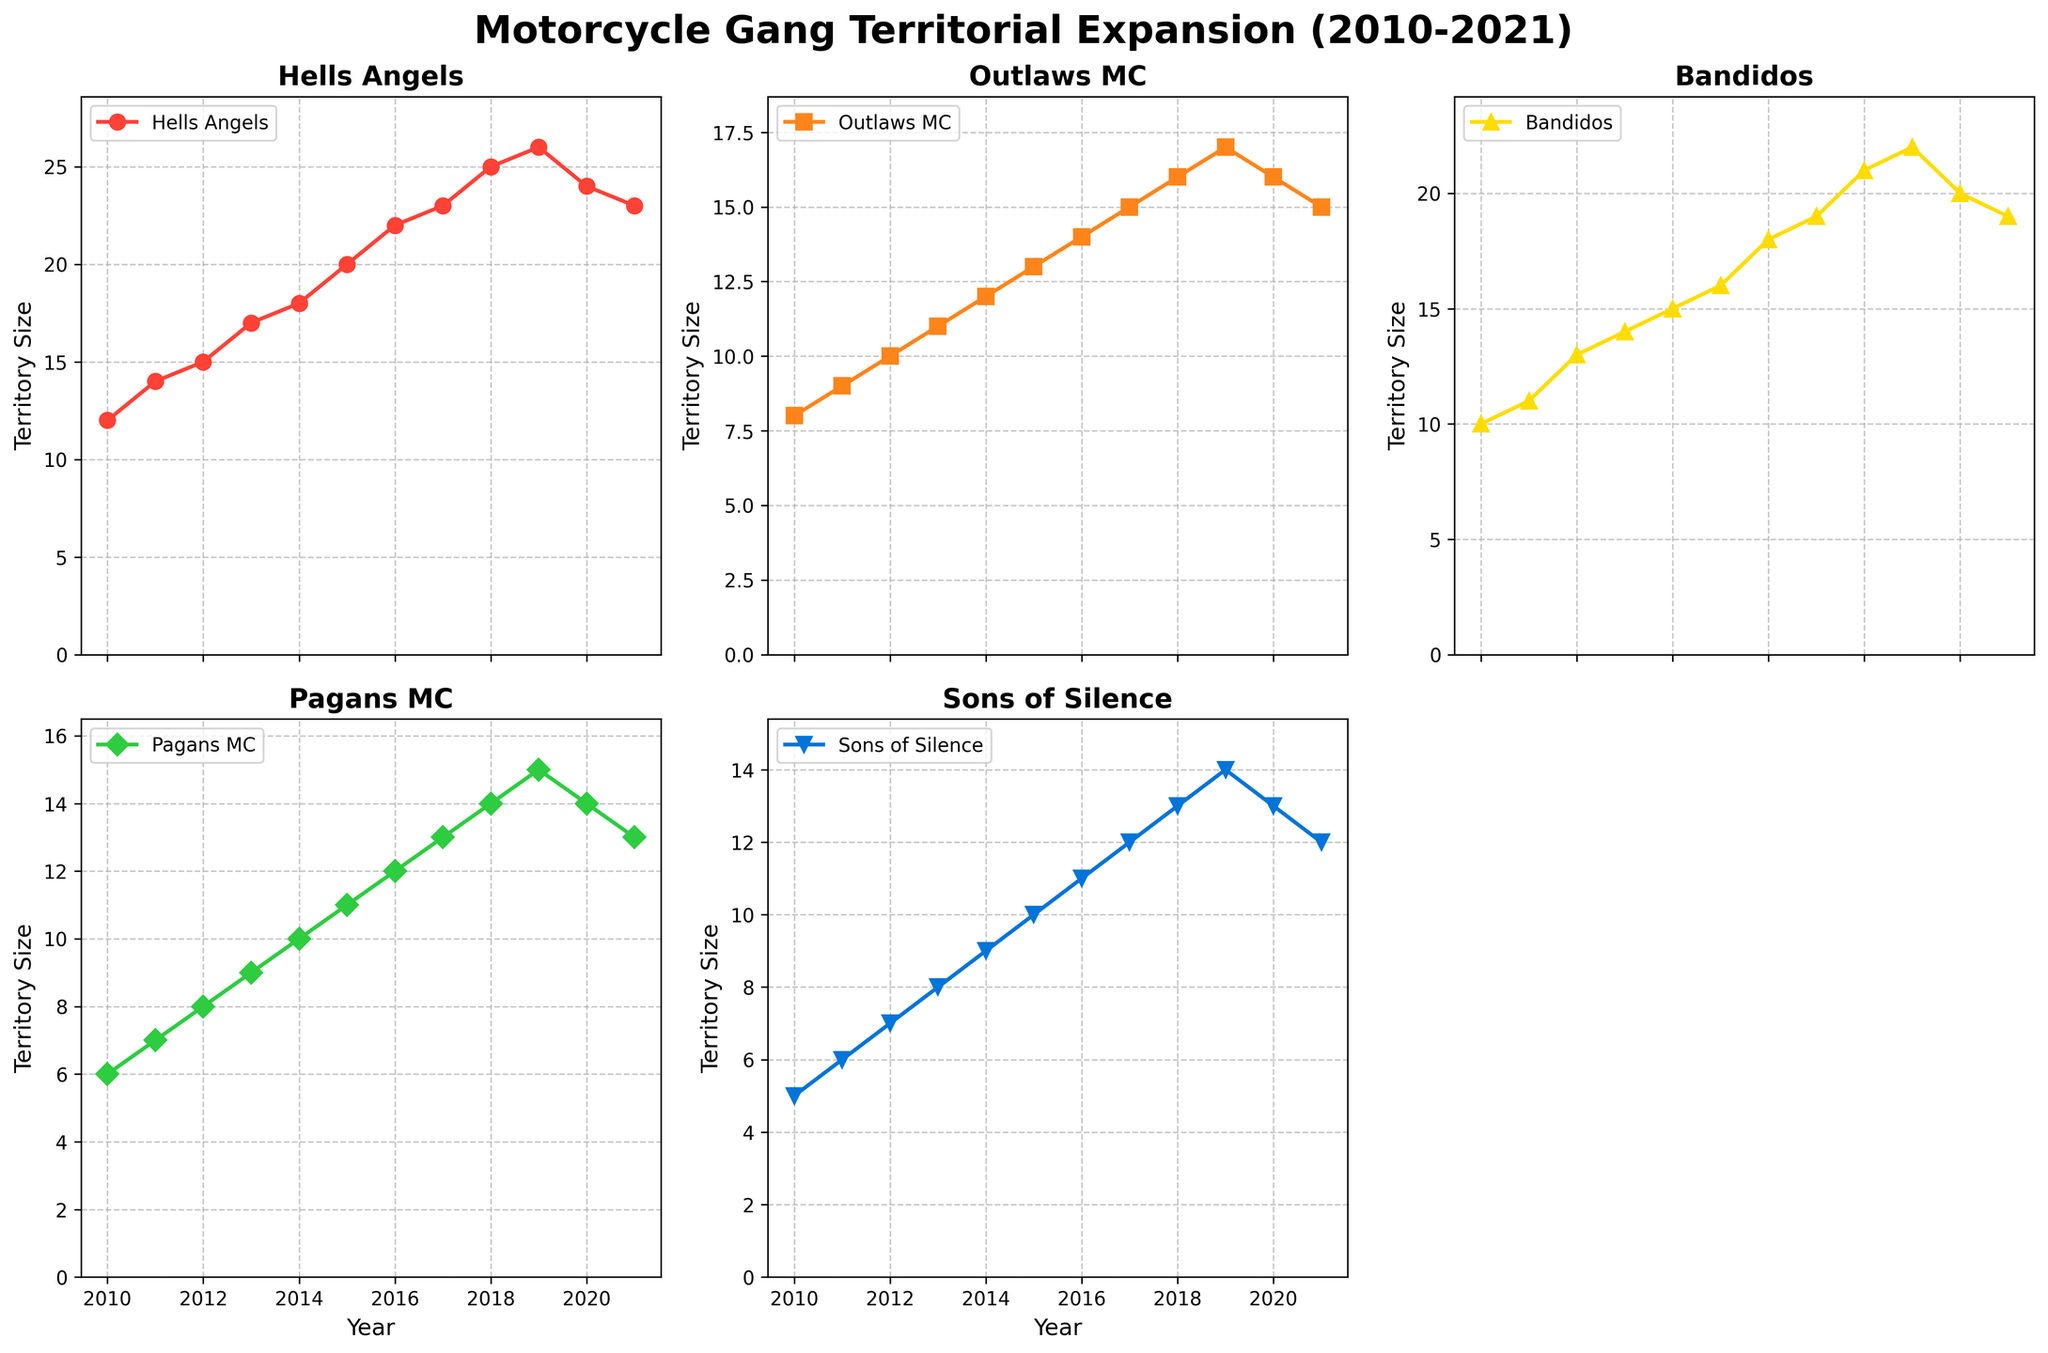What is the title of the figure? The title is in a larger, bold font at the top of the figure, summarizing the overall content of the plots.
Answer: Motorcycle Gang Territorial Expansion (2010-2021) Which motorcycle gang had the largest territory in 2020? By looking at the 2020 data points across all subplots, find which line reaches the highest value.
Answer: Hells Angels How did the territory size of the Pagans MC change between 2015 and 2017? Find the values at 2015 and 2017 in the Pagans MC subplot and calculate the difference. In 2015, Pagans MC had a territory size of 11, and in 2017, it was 13. The size increased by 2.
Answer: Increased by 2 What trend did the territory size of Sons of Silence show from 2018 to 2021? Examine the slope of the line in the Sons of Silence subplot from 2018 to 2021. The territory size decreased from 13 in 2018 to 12 in 2021.
Answer: Decreasing Which motorcycle gang experienced the most notable contraction in territory size from 2019 to 2021? Identify the gang whose line exhibits the largest drop between 2019 and 2021. Hells Angels' territory size drops from 26 in 2019 to 23 in 2021.
Answer: Hells Angels How many gangs showed an increase in territory size from 2010 to 2021? For each subplot, compare the territory size in 2010 and 2021. All gangs except one showed an increase. Sons of Silence remained the same.
Answer: Four What was the average territory size of Bandidos in the first three years (2010-2012)? Add the territory sizes for 2010, 2011, and 2012 and then divide by 3. (10 + 11 + 13)/3 = 34/3 ≈ 11.33
Answer: 11.33 Compare the territory size of Outlaws MC and Sons of Silence in 2016. Which one was larger? Find the data points for both Outlaws MC and Sons of Silence in 2016 and compare. Outlaws MC had 14, and Sons of Silence had 11. Outlaws MC is larger.
Answer: Outlaws MC What color represents the Pagans MC in the figure? The subplot titles and their corresponding lines are color-coded. The color used for Pagans MC should be identified.
Answer: Green 